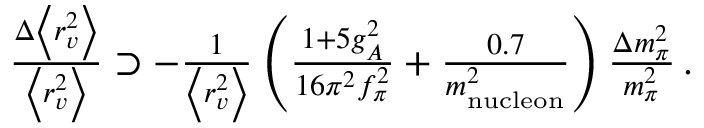Convert formula to latex. <formula><loc_0><loc_0><loc_500><loc_500>\begin{array} { r } { \frac { \Delta \left < r _ { v } ^ { 2 } \right > } { \left < r _ { v } ^ { 2 } \right > } \supset - \frac { 1 } { \left < r _ { v } ^ { 2 } \right > } \left ( \frac { 1 + 5 g _ { A } ^ { 2 } } { 1 6 \pi ^ { 2 } f _ { \pi } ^ { 2 } } + \frac { 0 . 7 } { m _ { n u c l e o n } ^ { 2 } } \right ) \frac { \Delta m _ { \pi } ^ { 2 } } { m _ { \pi } ^ { 2 } } \, . } \end{array}</formula> 